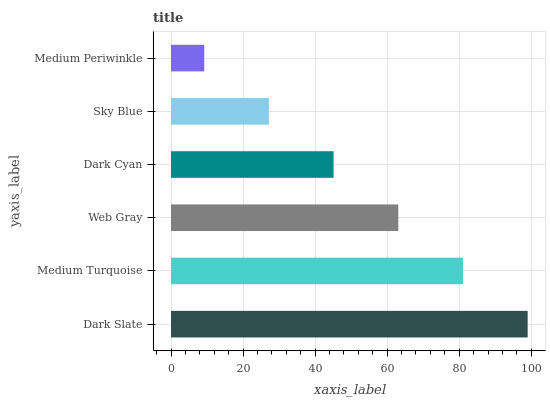Is Medium Periwinkle the minimum?
Answer yes or no. Yes. Is Dark Slate the maximum?
Answer yes or no. Yes. Is Medium Turquoise the minimum?
Answer yes or no. No. Is Medium Turquoise the maximum?
Answer yes or no. No. Is Dark Slate greater than Medium Turquoise?
Answer yes or no. Yes. Is Medium Turquoise less than Dark Slate?
Answer yes or no. Yes. Is Medium Turquoise greater than Dark Slate?
Answer yes or no. No. Is Dark Slate less than Medium Turquoise?
Answer yes or no. No. Is Web Gray the high median?
Answer yes or no. Yes. Is Dark Cyan the low median?
Answer yes or no. Yes. Is Dark Slate the high median?
Answer yes or no. No. Is Dark Slate the low median?
Answer yes or no. No. 